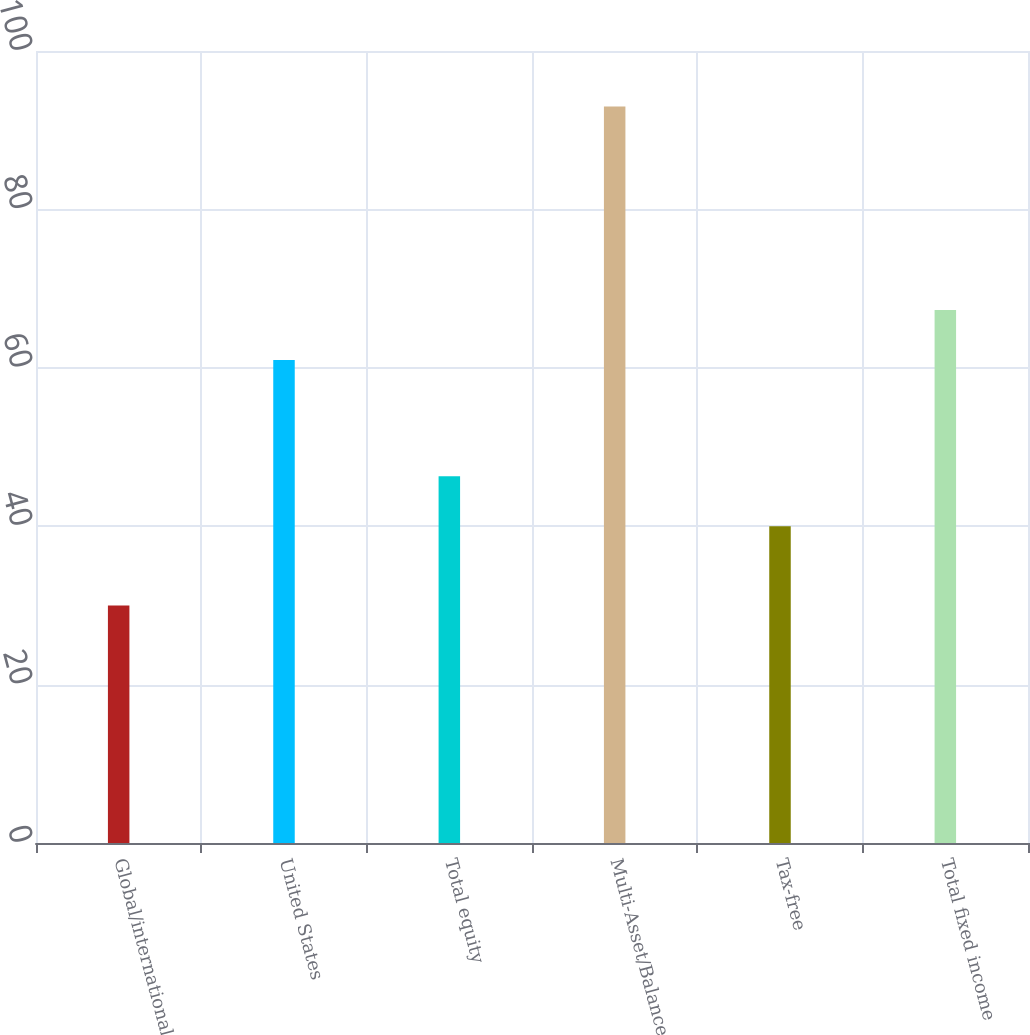<chart> <loc_0><loc_0><loc_500><loc_500><bar_chart><fcel>Global/international<fcel>United States<fcel>Total equity<fcel>Multi-Asset/Balanced<fcel>Tax-free<fcel>Total fixed income<nl><fcel>30<fcel>61<fcel>46.3<fcel>93<fcel>40<fcel>67.3<nl></chart> 